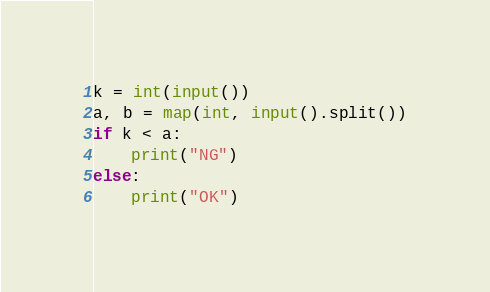Convert code to text. <code><loc_0><loc_0><loc_500><loc_500><_Python_>k = int(input())
a, b = map(int, input().split())
if k < a:
    print("NG")
else:
    print("OK")</code> 